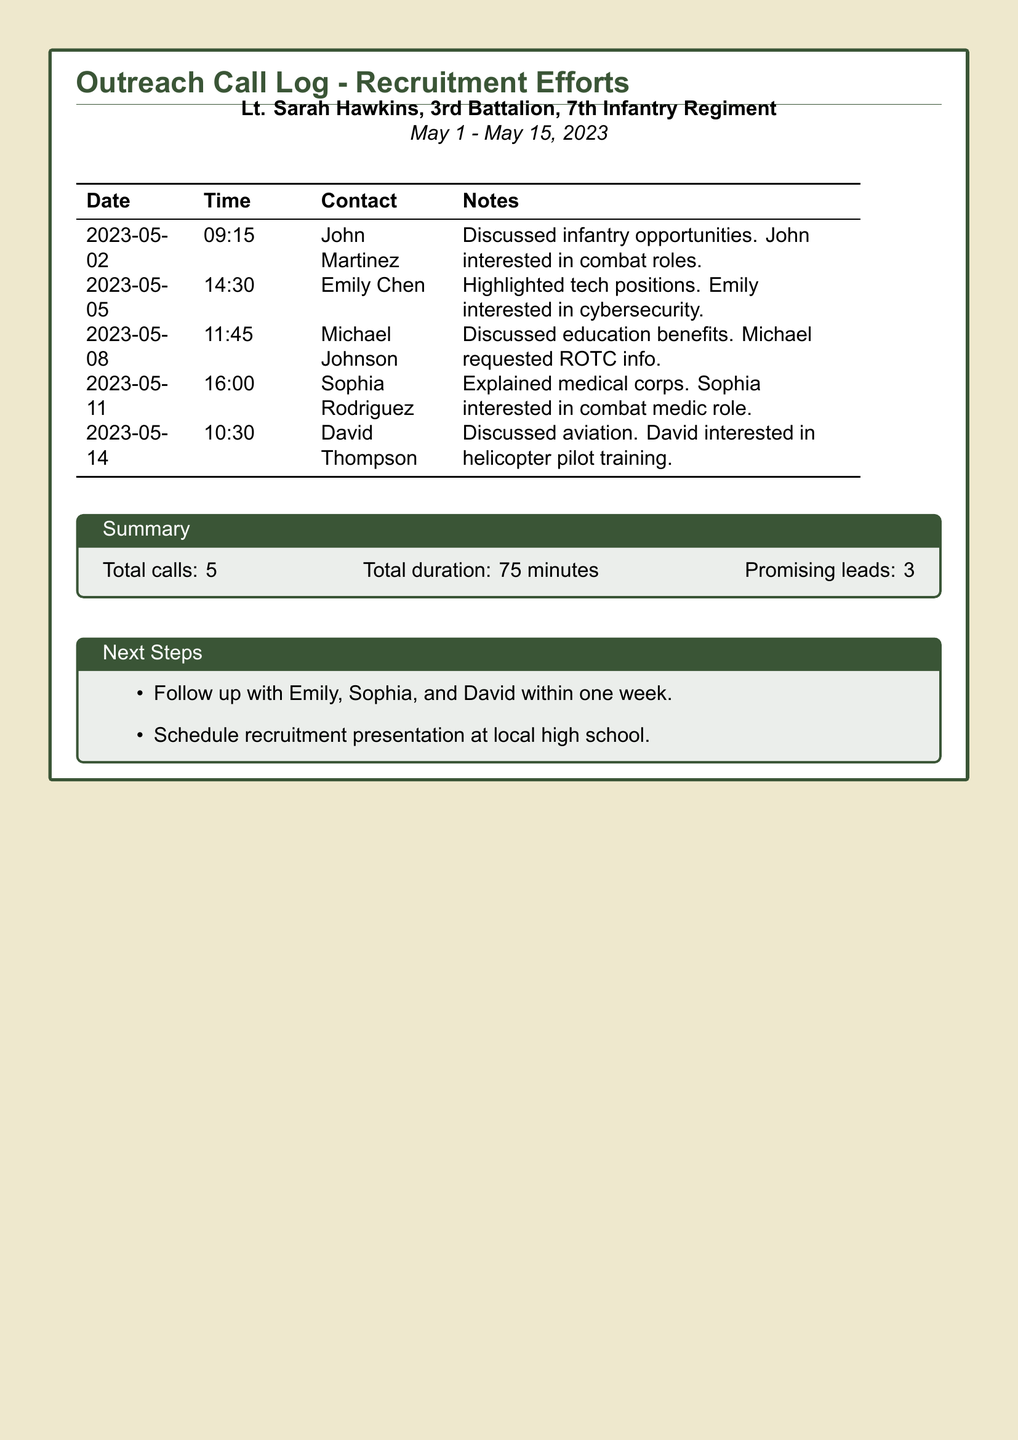What is the name of the lieutenant? The lieutenant's name is shown in the title of the document.
Answer: Lt. Sarah Hawkins What is the total number of calls made? This is listed in the summary section of the document.
Answer: 5 On which date was the call to Sophia Rodriguez made? The date of the call is listed next to the contact in the table.
Answer: 2023-05-11 Which position did Emily Chen show interest in? This information is noted in the notes section of her call entry.
Answer: Cybersecurity How many promising leads were identified? The total number of promising leads is indicated in the summary section.
Answer: 3 What was discussed during the call with Michael Johnson? The content of the conversation can be found in the notes section.
Answer: Education benefits When is the follow-up planned for the leads? The next steps indicate when the follow-up should occur.
Answer: Within one week What role is David Thompson interested in? This information is provided in the notes section of the document.
Answer: Helicopter pilot training What was the total duration of all calls? The total duration is mentioned in the summary section.
Answer: 75 minutes 